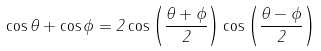Convert formula to latex. <formula><loc_0><loc_0><loc_500><loc_500>\cos \theta + \cos \phi = 2 \cos \left ( { \frac { \theta + \phi } { 2 } } \right ) \cos \left ( { \frac { \theta - \phi } { 2 } } \right )</formula> 